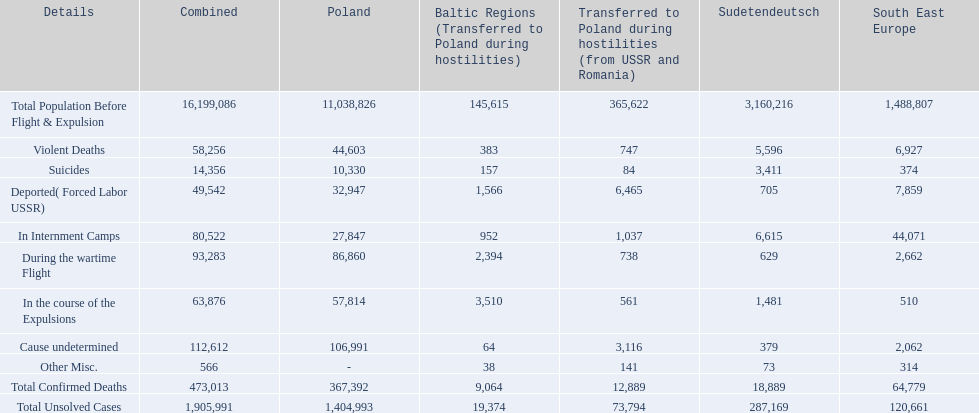What are all of the descriptions? Total Population Before Flight & Expulsion, Violent Deaths, Suicides, Deported( Forced Labor USSR), In Internment Camps, During the wartime Flight, In the course of the Expulsions, Cause undetermined, Other Misc., Total Confirmed Deaths, Total Unsolved Cases. What were their total number of deaths? 16,199,086, 58,256, 14,356, 49,542, 80,522, 93,283, 63,876, 112,612, 566, 473,013, 1,905,991. What about just from violent deaths? 58,256. 